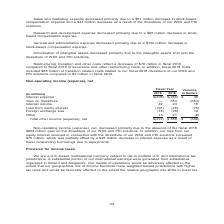According to Nortonlifelock's financial document, What does this table show? Non-operating income (expense), net. The document states: "Non-operating income (expense), net..." Also, What was the primary reason for the decrease in Non-operating income (expense), net? the absence of the fiscal 2018 $653 million gain on the divestiture of our WSS and PKI solutions. The document states: "income (expense), net, decreased primarily due to the absence of the fiscal 2018 $653 million gain on the divestiture of our WSS and PKI solutions. In..." Also,  What was the Total other income (expense), net for fiscal year 2019?  According to the financial document, (272) (in millions). The relevant text states: "Total other income (expense), net $(272) $ 388 $ (660)..." Also, can you calculate: What was the percentage change in income from fiscal 2018 to fiscal 2019? To answer this question, I need to perform calculations using the financial data. The calculation is: -660/388, which equals -170.1 (percentage). This is based on the information: "Total other income (expense), net $(272) $ 388 $ (660) Total other income (expense), net $(272) $ 388 $ (660)..." The key data points involved are: 388, 660. Also, can you calculate: What was the total other income (expense), net for both fiscal years? Based on the calculation: -272+388, the result is 116 (in millions). This is based on the information: "Total other income (expense), net $(272) $ 388 $ (660) Total other income (expense), net $(272) $ 388 $ (660)..." The key data points involved are: 272, 388. Also, can you calculate: What is the average Total other income (expense), net for fiscal 2019 and fiscal 2018? To answer this question, I need to perform calculations using the financial data. The calculation is: (-272+388)/2, which equals 58 (in millions). This is based on the information: "Total other income (expense), net $(272) $ 388 $ (660) Total other income (expense), net $(272) $ 388 $ (660)..." The key data points involved are: 272, 388. 